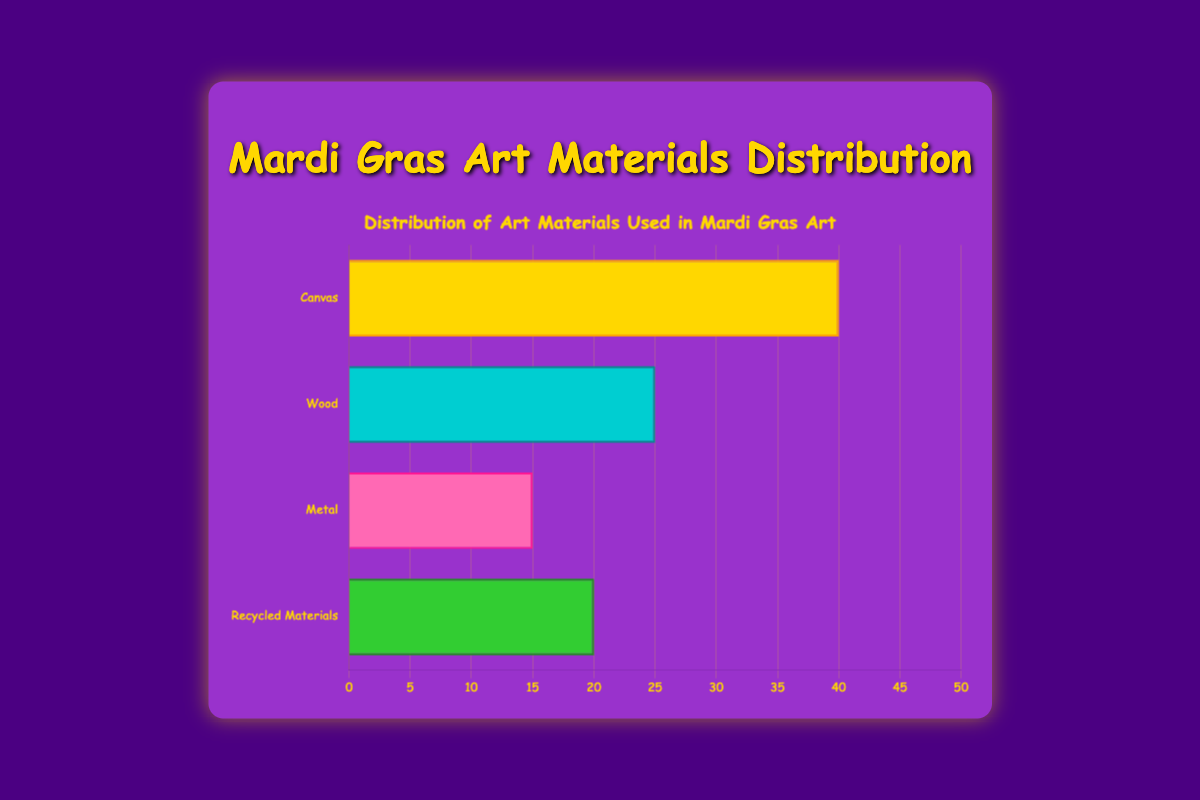Which material is used the most in Mardi Gras art? The bar representing Canvas reaches the highest percentage, indicating it is used the most.
Answer: Canvas Which material is used the least in Mardi Gras art? The bar representing Metal is the shortest, indicating it is used the least.
Answer: Metal What is the total percentage of art materials used excluding Canvas? Adding the percentages of Wood (25), Metal (15), and Recycled Materials (20): 25 + 15 + 20 = 60
Answer: 60 How much more is Canvas used compared to Wood? Subtract Wood's percentage (25) from Canvas's percentage (40): 40 - 25 = 15
Answer: 15 Which two materials together make up the highest percentage of use? Canvas and Wood together: 40 + 25 = 65, which is higher than any other pair.
Answer: Canvas and Wood What is the average percentage use of Metal and Recycled Materials? Adding Metal's percentage (15) and Recycled Materials' percentage (20), then dividing by 2: (15 + 20) / 2 = 17.5
Answer: 17.5 Which material's use percentage is closest to 20%? The use percentage of Recycled Materials is exactly 20%, which is the closest.
Answer: Recycled Materials How does the use of Recycled Materials compare to Metal? Recycled Materials (20) is used more than Metal (15).
Answer: Recycled Materials What is the difference between the highest and lowest percentage materials? Subtract the percentage of Metal (15) from Canvas (40): 40 - 15 = 25
Answer: 25 Are there any two materials with equal use percentages? By comparing the percentages, none of the materials have equal use.
Answer: No 